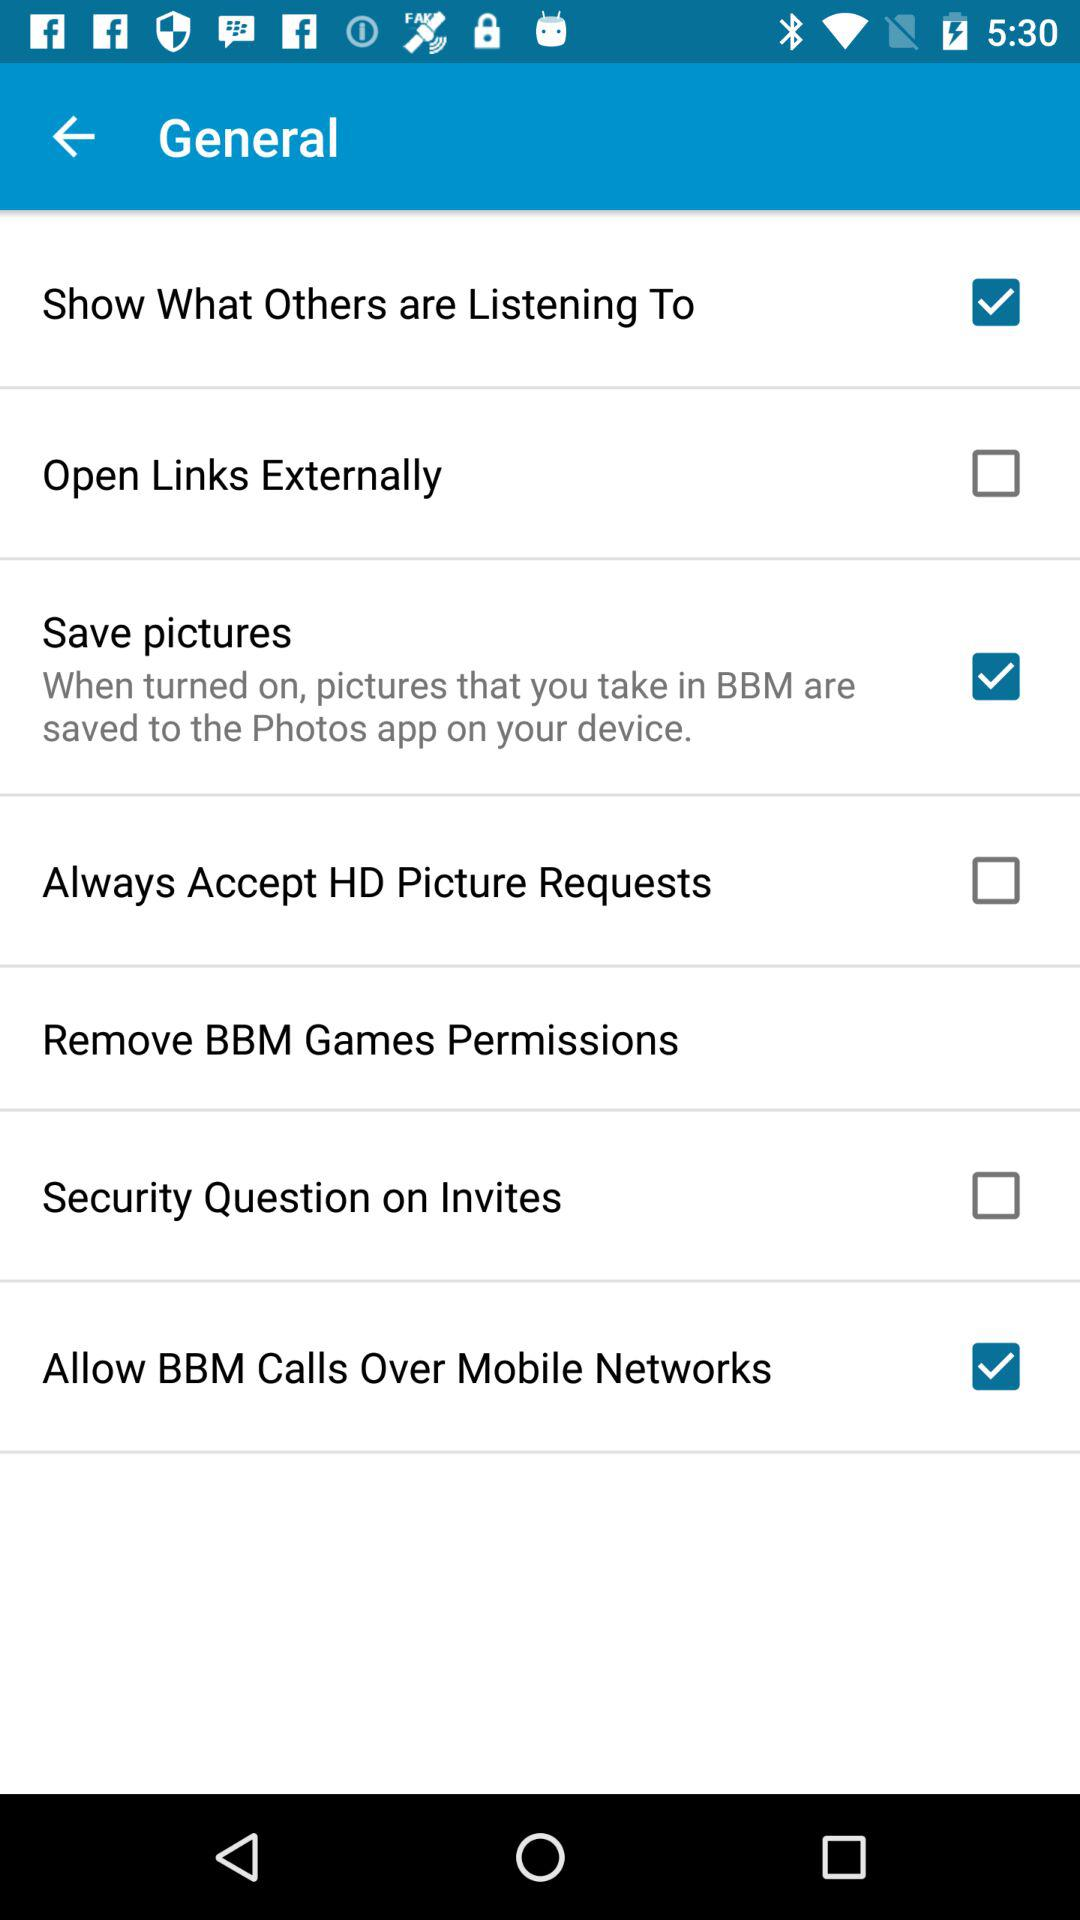What is the setting for the open links externally? The setting for the open links externally is "off". 